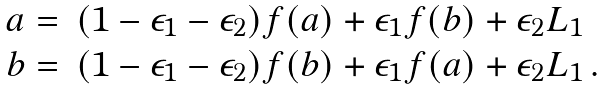Convert formula to latex. <formula><loc_0><loc_0><loc_500><loc_500>\begin{array} { l l } a = & ( 1 - \epsilon _ { 1 } - \epsilon _ { 2 } ) f ( a ) + \epsilon _ { 1 } f ( b ) + \epsilon _ { 2 } L _ { 1 } \\ b = & ( 1 - \epsilon _ { 1 } - \epsilon _ { 2 } ) f ( b ) + \epsilon _ { 1 } f ( a ) + \epsilon _ { 2 } L _ { 1 } \, . \end{array}</formula> 